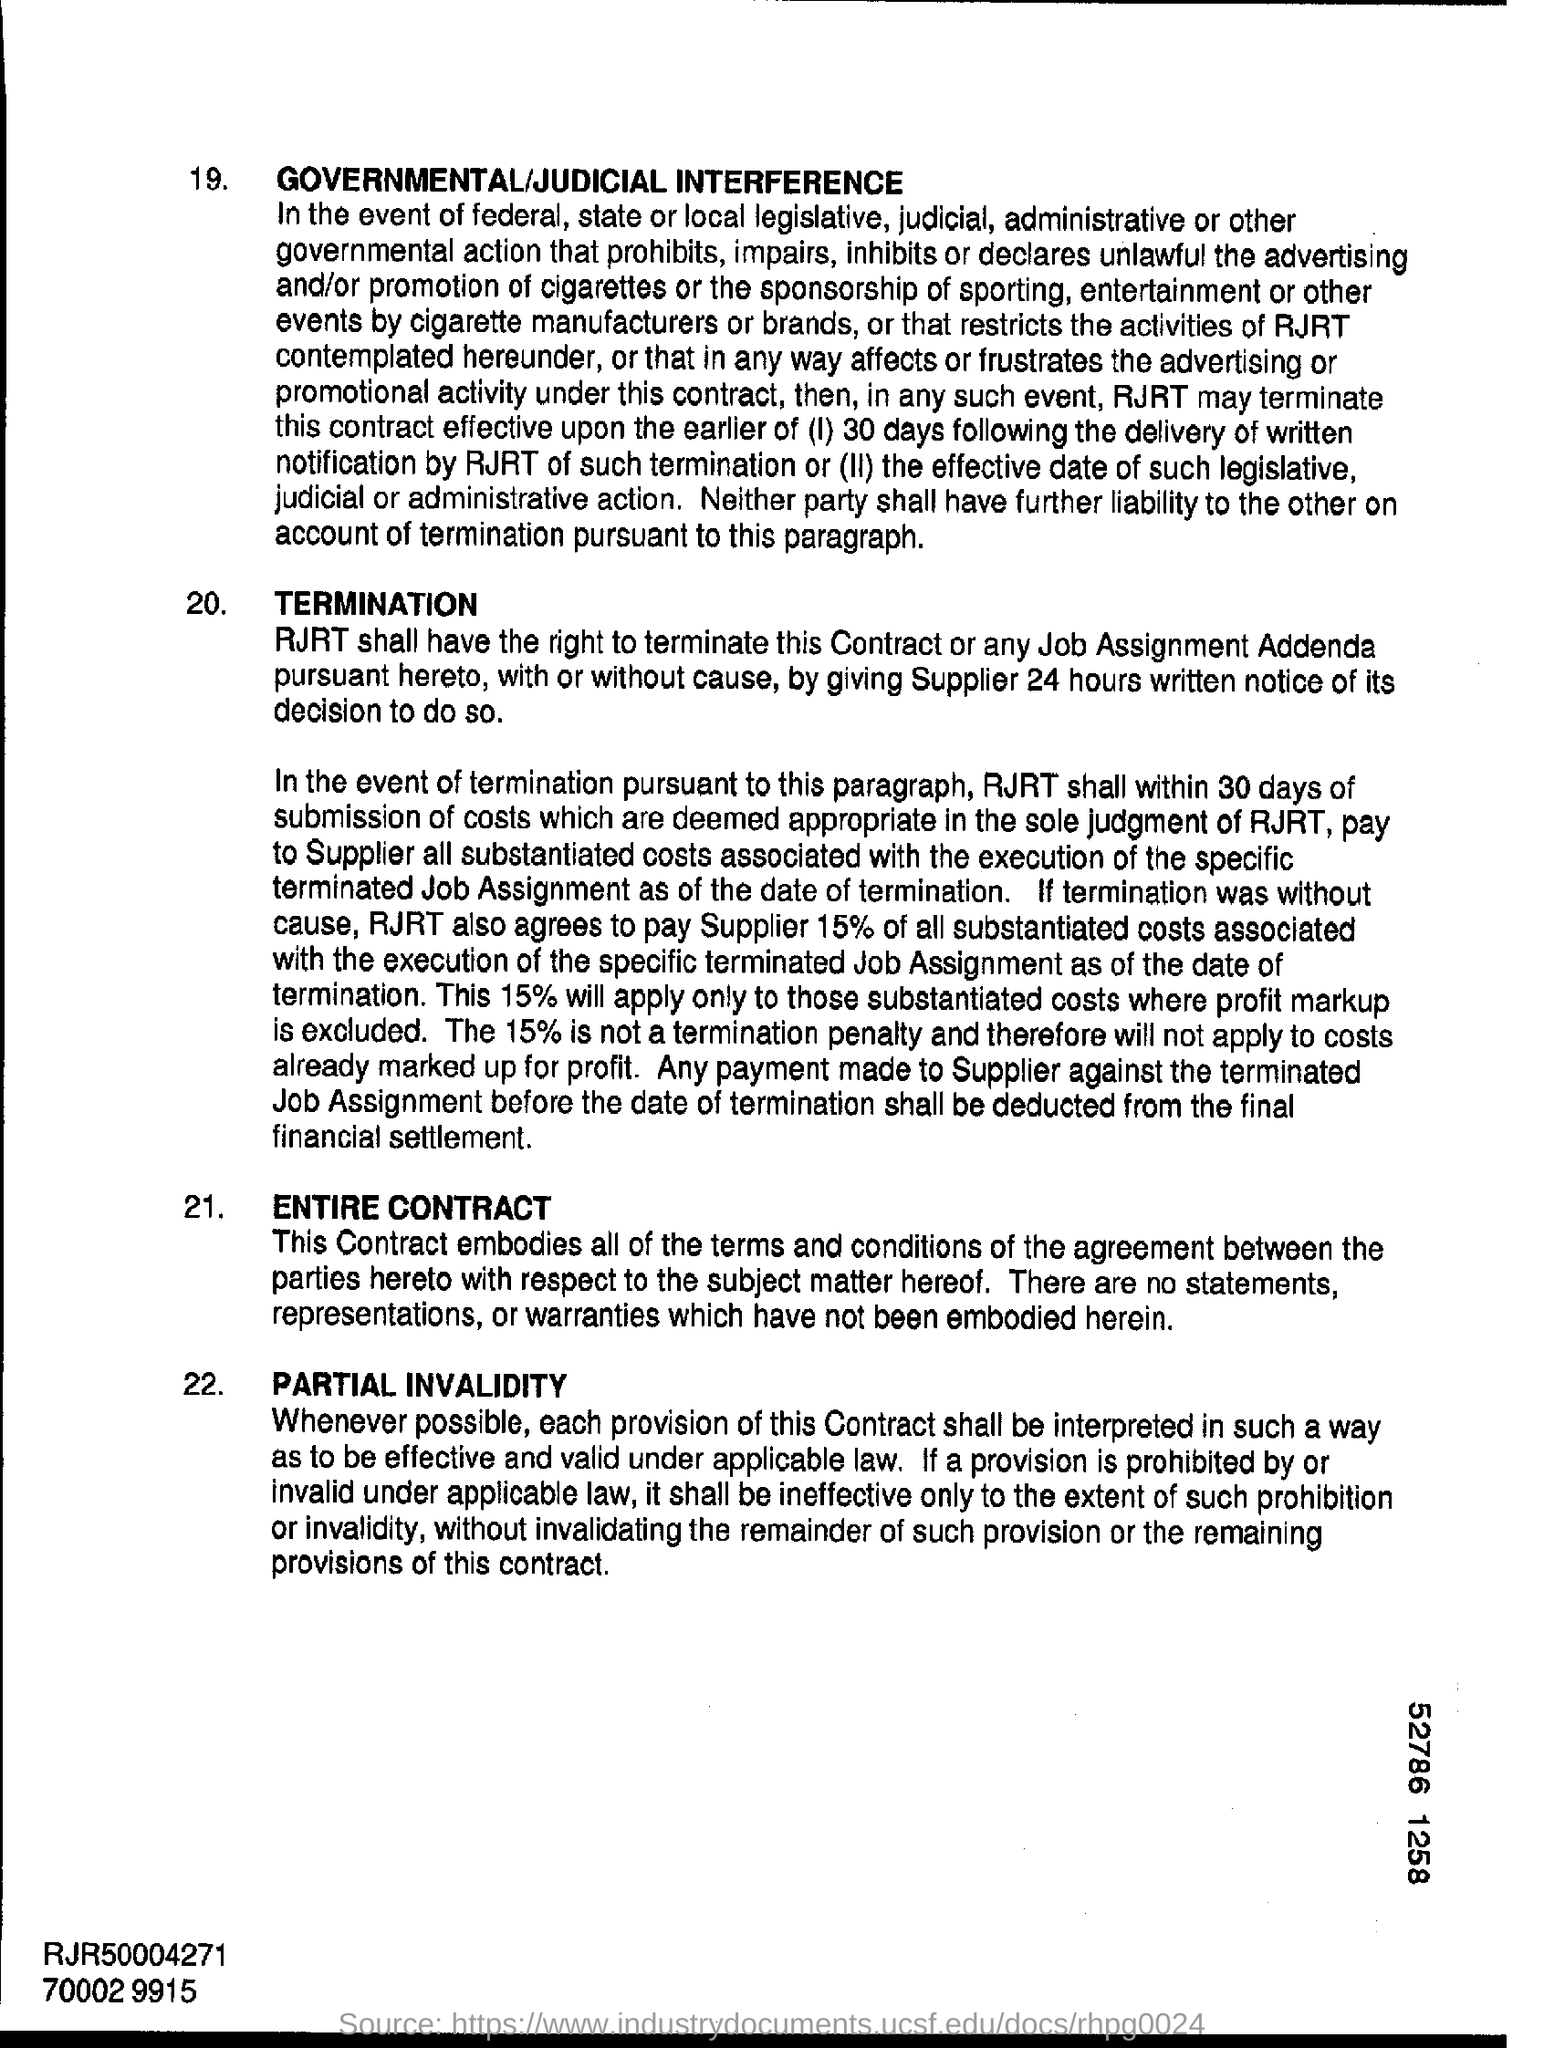What is digit shown at the bottom right corner?
Keep it short and to the point. 52786 1258. 